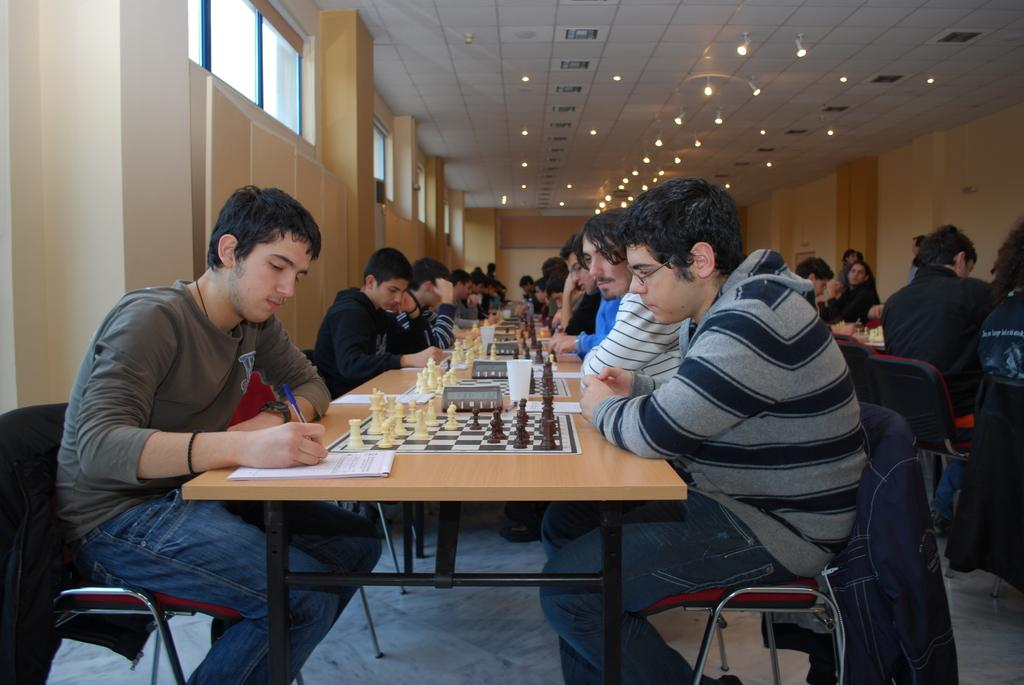How many people are in the image? There is a group of people in the image. What are the people doing in the image? The people are playing chess. What furniture can be seen in the image? The people are sitting on chairs, and there is a table near them. What can be seen on the ceiling in the image? There are lights on the ceiling. What architectural feature is present on the walls in the image? There are windows on the walls. What type of yak can be seen in the image? There is no yak present in the image. Is the carpenter working on any furniture in the image? There is no carpenter or any furniture-making activity depicted in the image. 